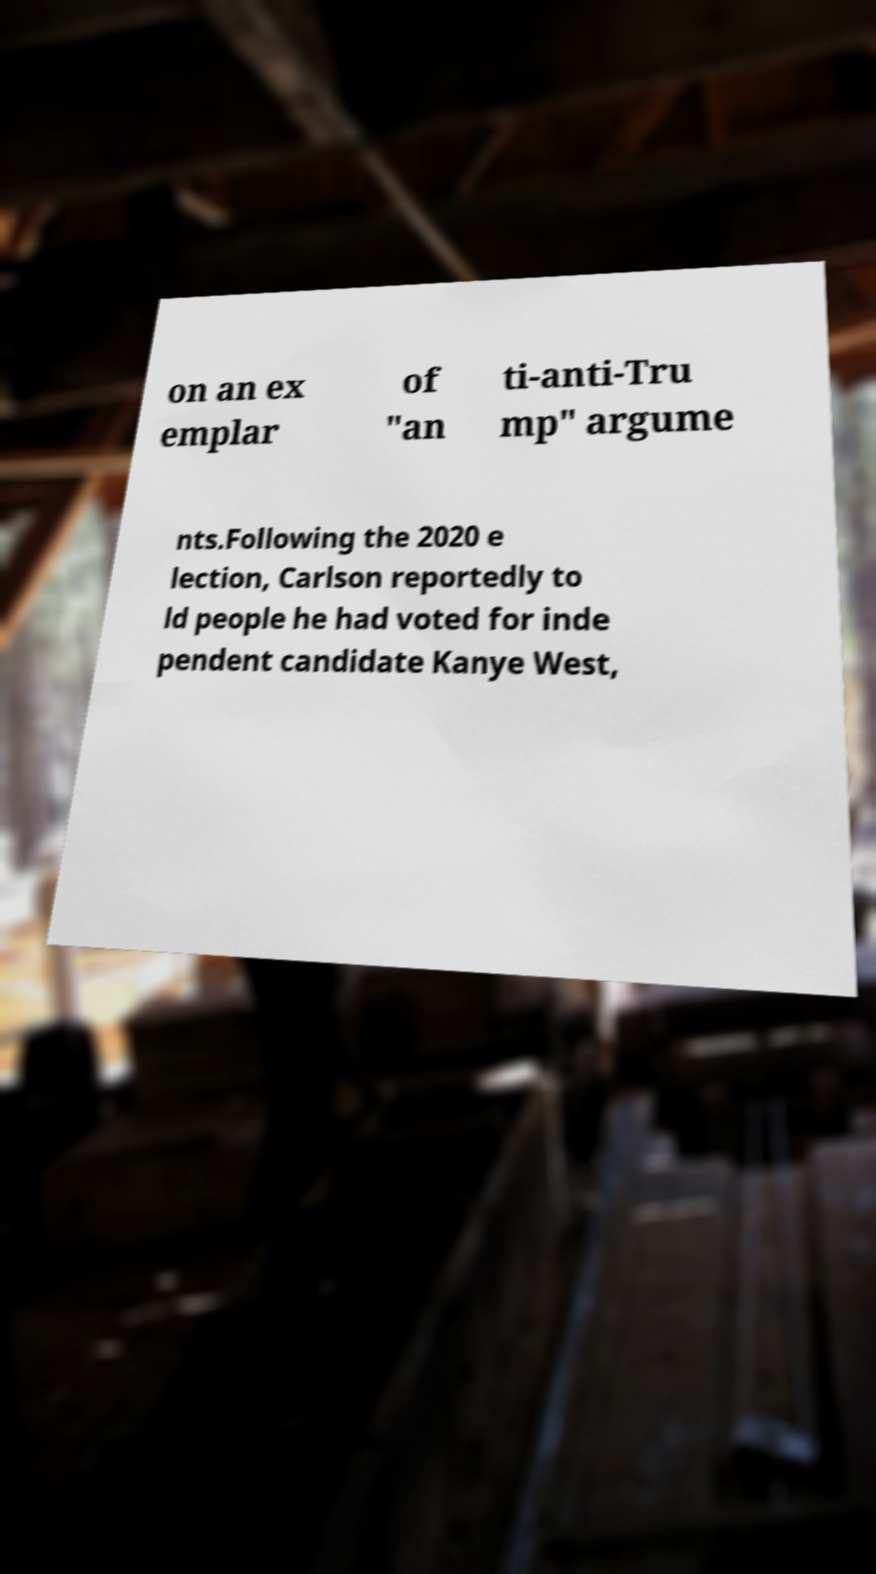Could you assist in decoding the text presented in this image and type it out clearly? on an ex emplar of "an ti-anti-Tru mp" argume nts.Following the 2020 e lection, Carlson reportedly to ld people he had voted for inde pendent candidate Kanye West, 